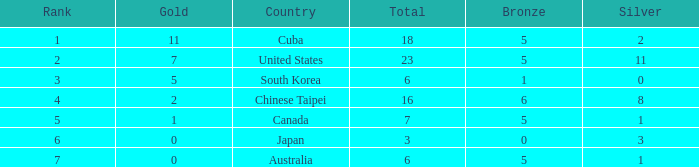What is the sum of the bronze medals when there were more than 2 silver medals and a rank larger than 6? None. 